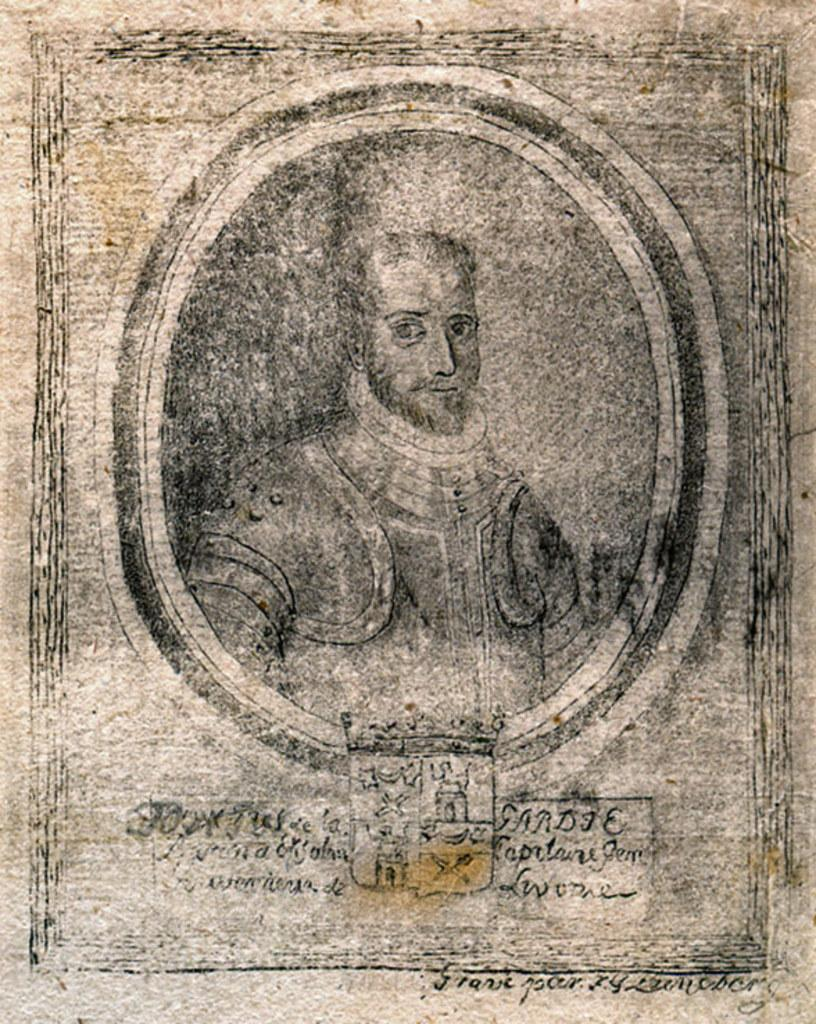What is the main subject of the image? The main subject of the image is an old stamp. Can you describe any text or writing on the stamp? Yes, there is writing on the stamp. What type of bottle is being used by the boys on the team in the image? There is no bottle or team of boys present in the image; it only features an old stamp with writing on it. 